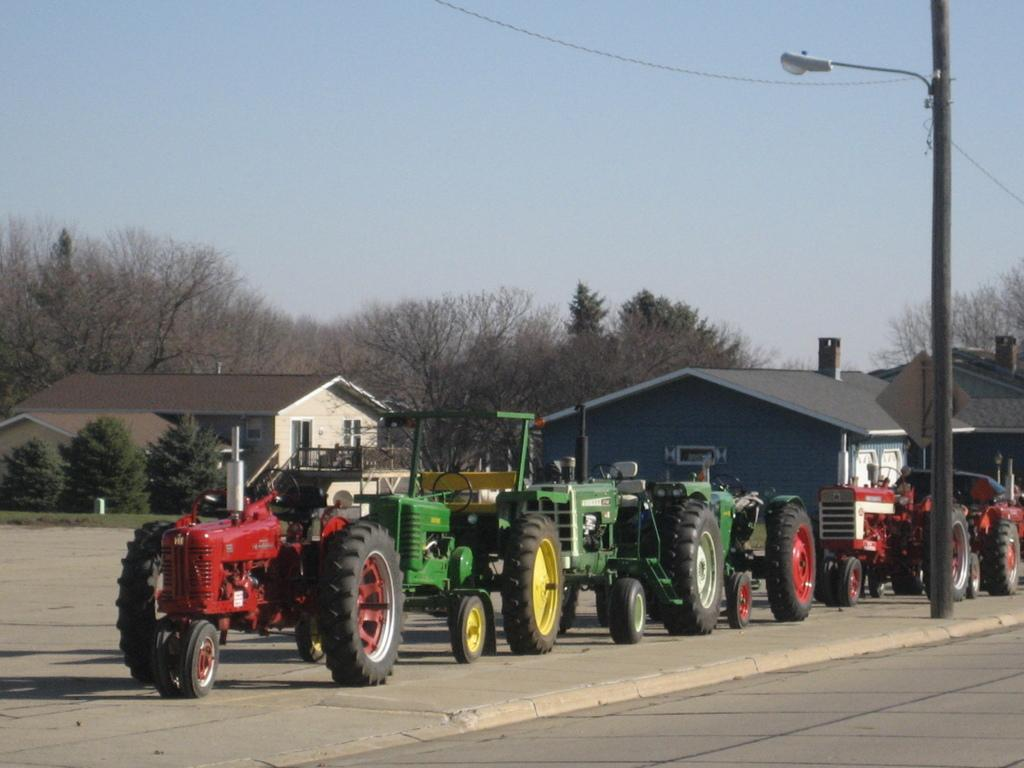What types of objects can be seen in the image? There are vehicles, houses, trees, and a pole in the image. Can you describe the environment in the image? The image shows a combination of urban and natural elements, with houses, vehicles, and a pole representing the urban aspect, and trees representing the natural aspect. What is visible in the background of the image? The sky is visible in the background of the image. What type of sound can be heard coming from the school in the image? There is no school present in the image, so it is not possible to determine what, if any, sounds might be heard. 